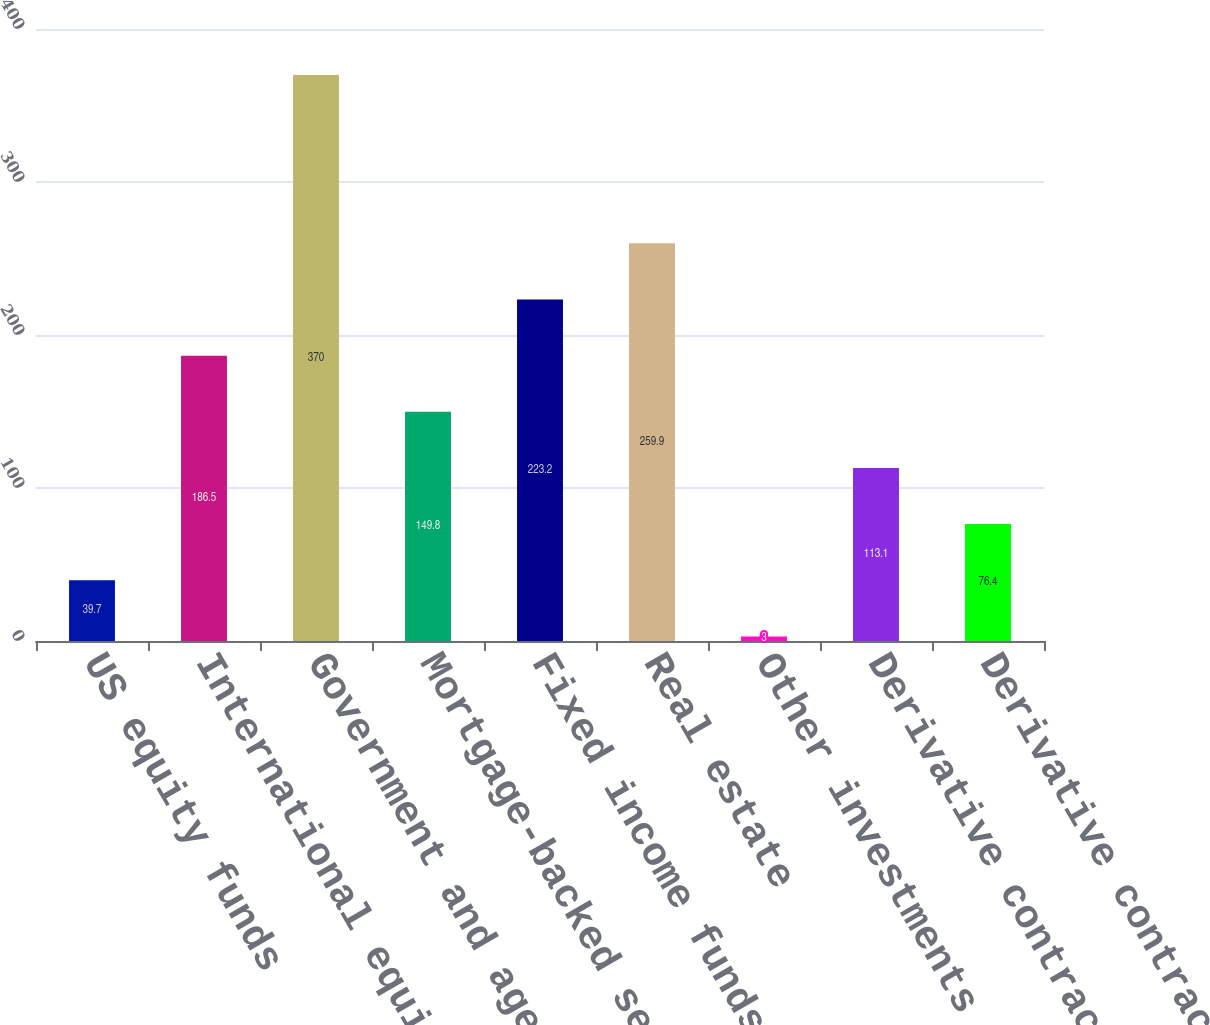Convert chart. <chart><loc_0><loc_0><loc_500><loc_500><bar_chart><fcel>US equity funds<fcel>International equity funds<fcel>Government and agency<fcel>Mortgage-backed securities<fcel>Fixed income funds<fcel>Real estate<fcel>Other investments<fcel>Derivative contracts - assets<fcel>Derivative contracts -<nl><fcel>39.7<fcel>186.5<fcel>370<fcel>149.8<fcel>223.2<fcel>259.9<fcel>3<fcel>113.1<fcel>76.4<nl></chart> 